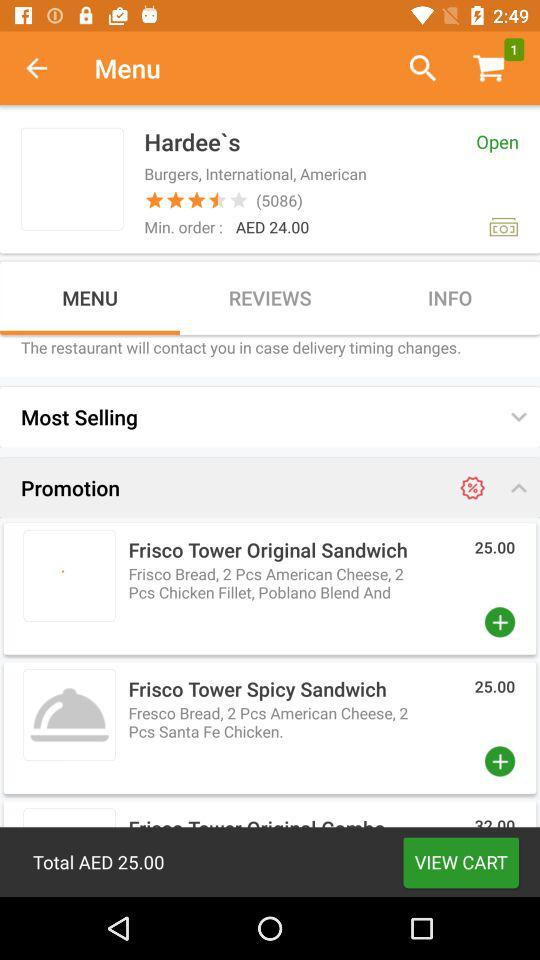What is the minimum price to order? The minimum price to order is AED 24.00. 